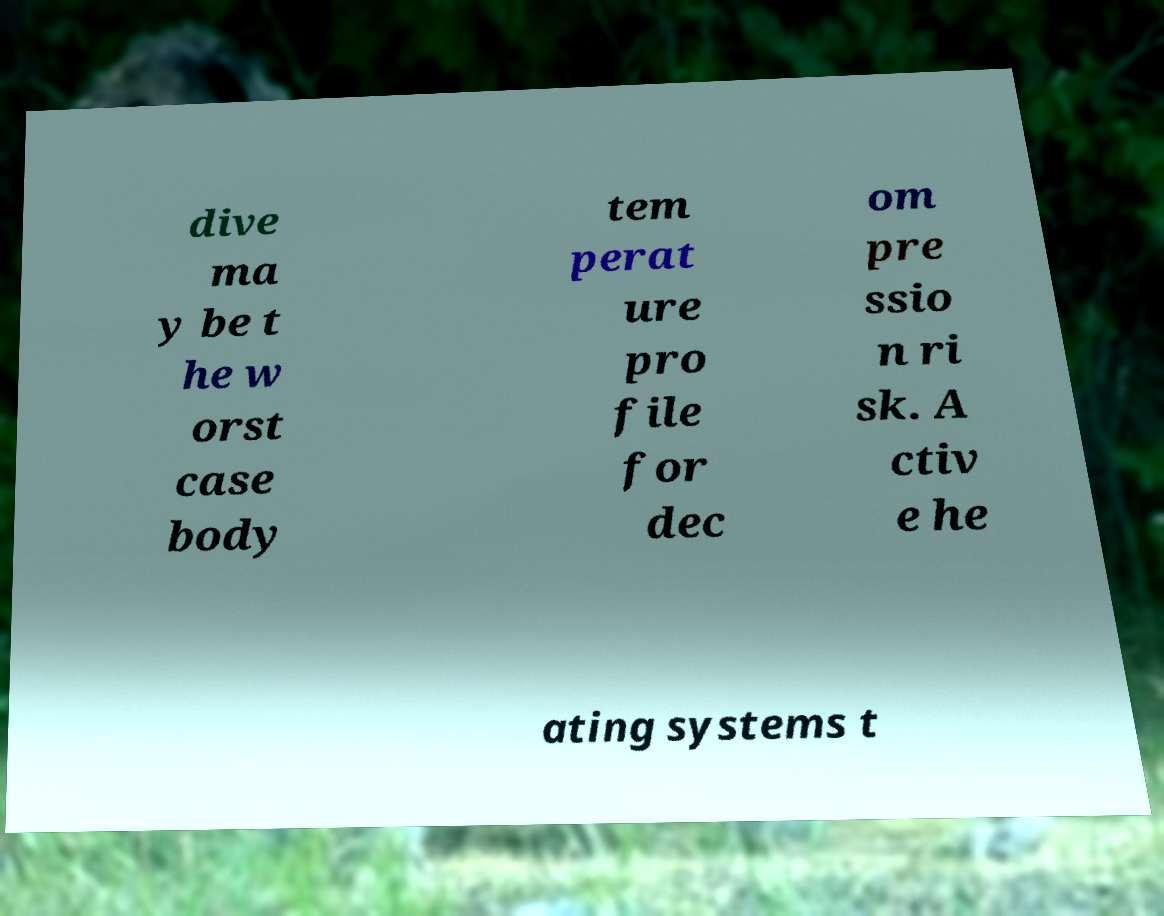Can you accurately transcribe the text from the provided image for me? dive ma y be t he w orst case body tem perat ure pro file for dec om pre ssio n ri sk. A ctiv e he ating systems t 